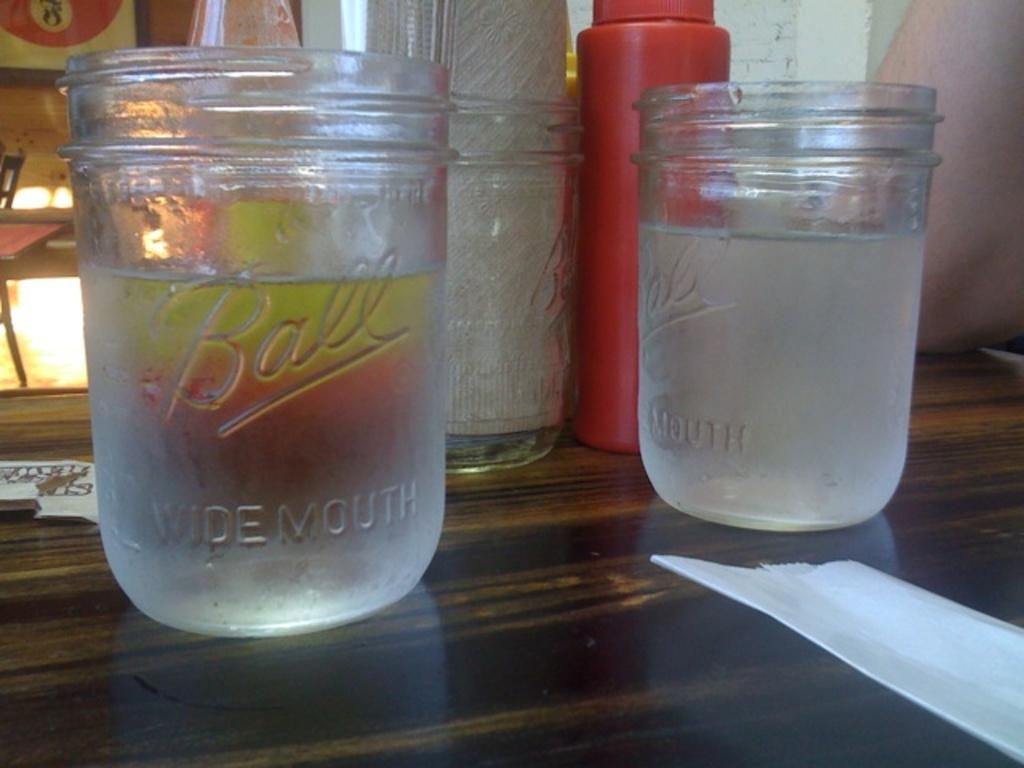<image>
Describe the image concisely. several BALL Widemouth jars on a wooden table 